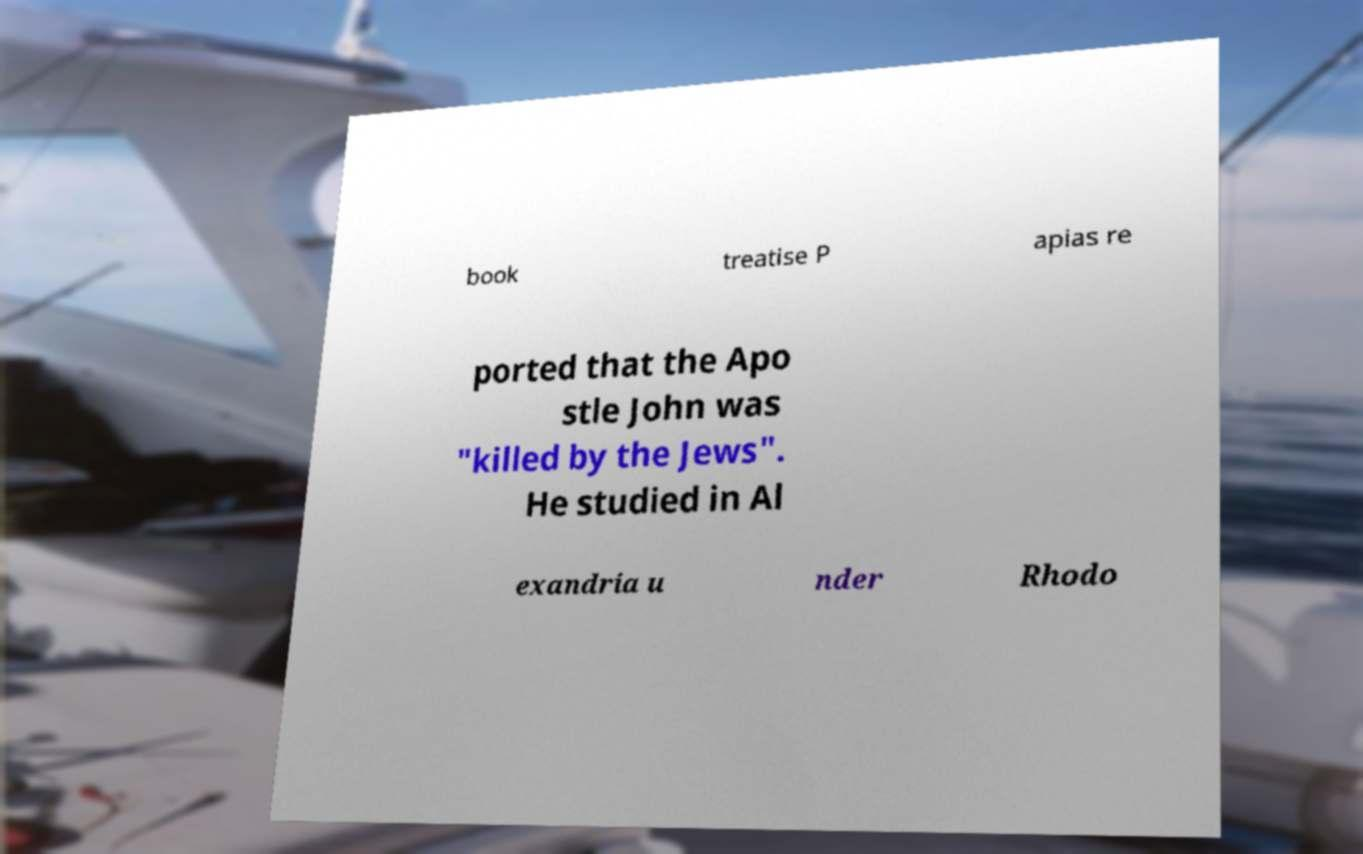Could you assist in decoding the text presented in this image and type it out clearly? book treatise P apias re ported that the Apo stle John was "killed by the Jews". He studied in Al exandria u nder Rhodo 